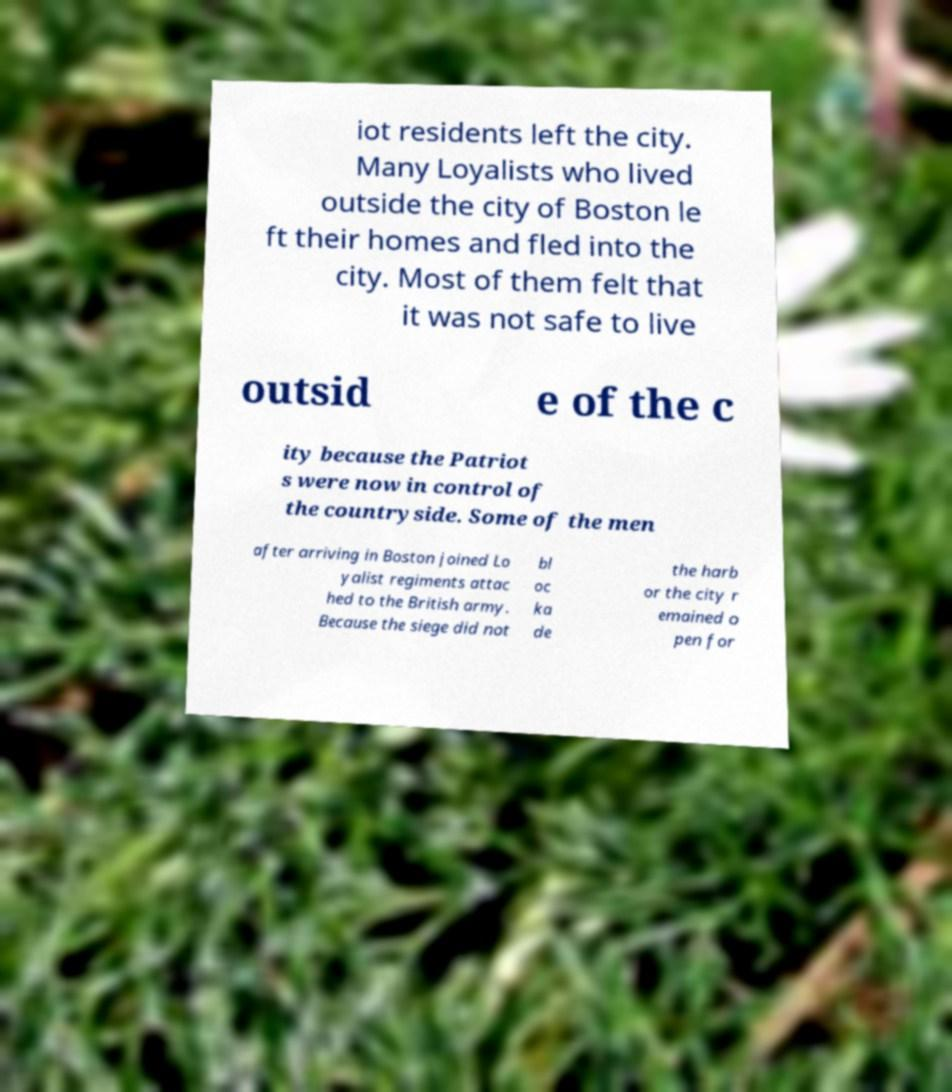I need the written content from this picture converted into text. Can you do that? iot residents left the city. Many Loyalists who lived outside the city of Boston le ft their homes and fled into the city. Most of them felt that it was not safe to live outsid e of the c ity because the Patriot s were now in control of the countryside. Some of the men after arriving in Boston joined Lo yalist regiments attac hed to the British army. Because the siege did not bl oc ka de the harb or the city r emained o pen for 